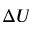<formula> <loc_0><loc_0><loc_500><loc_500>\Delta U</formula> 